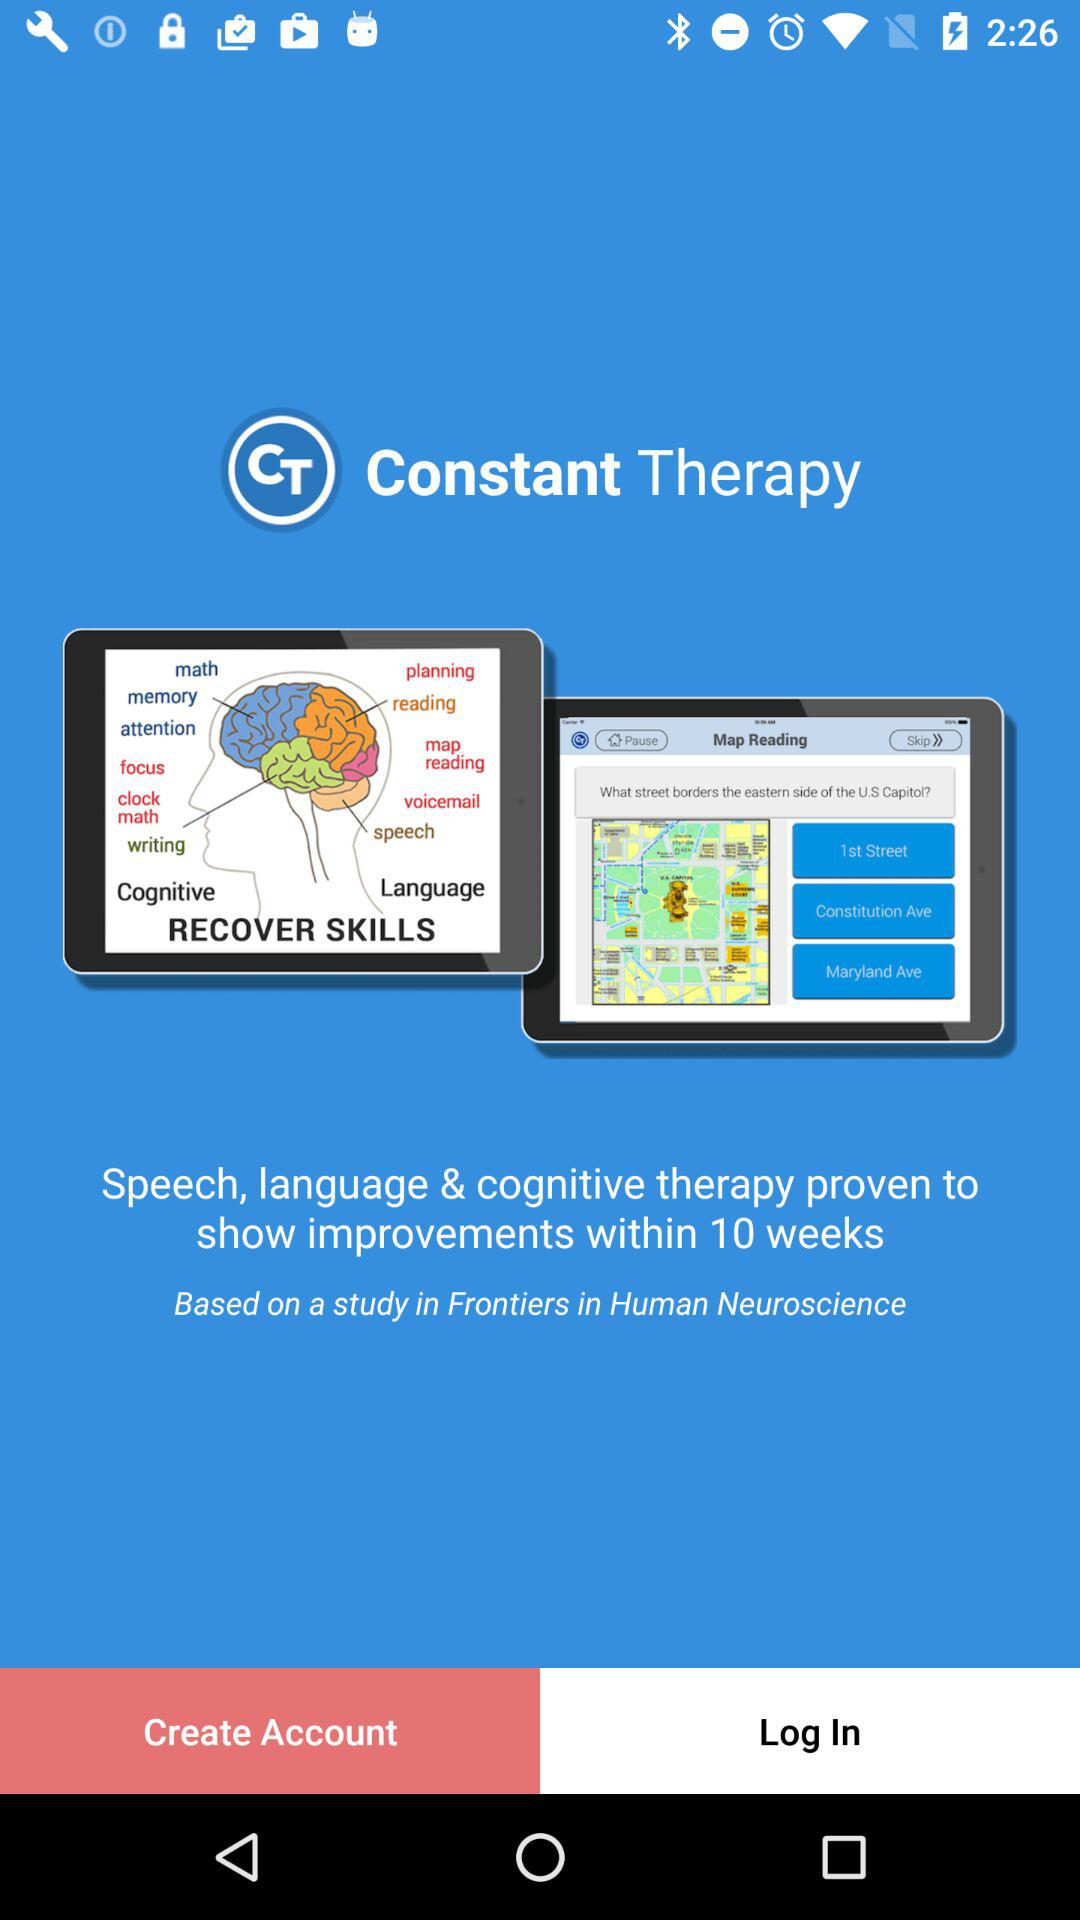What is the application name? The application name is "Constant Therapy". 